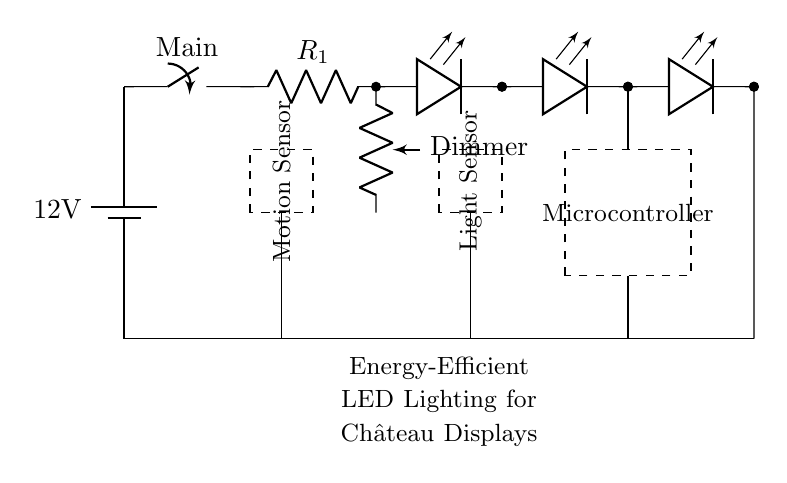What is the main voltage of this circuit? The voltage of the circuit is indicated by the battery symbol. It shows a potential difference of twelve volts supplied to the circuit.
Answer: twelve volts What type of switch is used in this circuit? The switch shown in the circuit is labeled as "Main," which is a simple on-off switch type used to control the power to the rest of the circuit.
Answer: Main switch How many LEDs are connected in series in this circuit? The diagram depicts three LED devices connected in series within the circuit. This is represented by three LED symbols aligned along the same path.
Answer: three What component is used to adjust the brightness of the LEDs? The circuit includes a dimmer potentiometer connected in the circuit, which allows for the adjustment of the LED brightness by varying the current.
Answer: Dimmer What is the role of the motion sensor in this circuit? The motion sensor is used to detect movement within the vicinity of the displays, enabling the lights to turn on or off based on presence, making the setup energy-efficient.
Answer: Detection of motion Which component is used to limit current in this circuit? A current limiting resistor, labeled as "R1," is present in the circuit to restrict the flow of current to safe levels for the LEDs, preventing damage due to excessive current.
Answer: Resistor What purpose does the microcontroller serve in the circuit? The microcontroller integrates with the motion sensor and light sensor, processing their data to control the LED lighting dynamically based on environmental conditions.
Answer: Control logic 